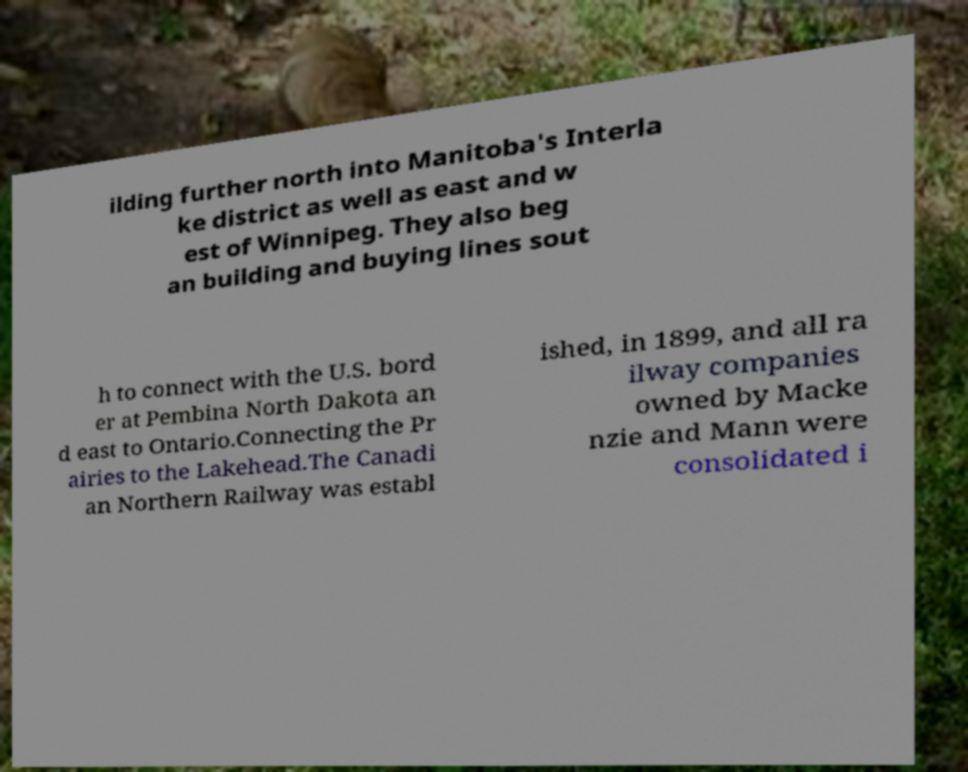What messages or text are displayed in this image? I need them in a readable, typed format. ilding further north into Manitoba's Interla ke district as well as east and w est of Winnipeg. They also beg an building and buying lines sout h to connect with the U.S. bord er at Pembina North Dakota an d east to Ontario.Connecting the Pr airies to the Lakehead.The Canadi an Northern Railway was establ ished, in 1899, and all ra ilway companies owned by Macke nzie and Mann were consolidated i 